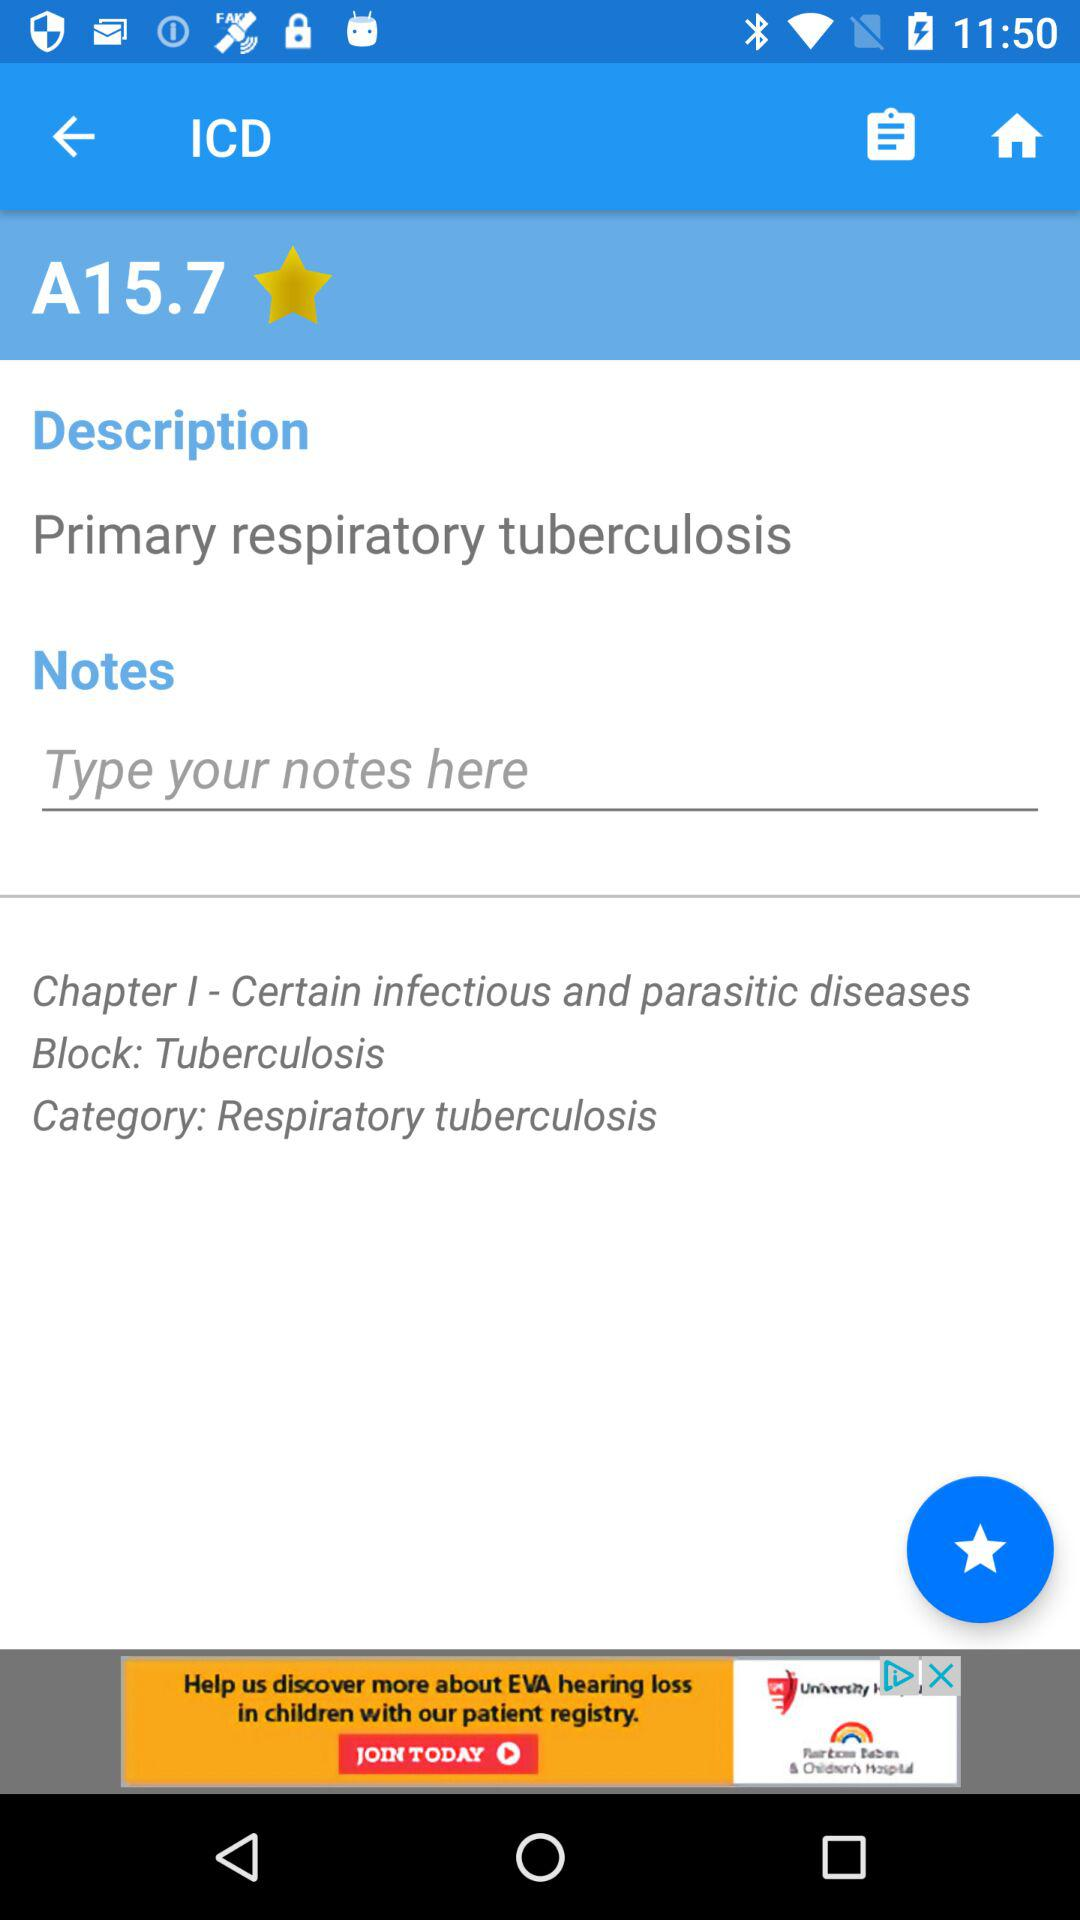What is the name of "Chapter 1"? The name is "Certain infectious and parasitic diseases". 